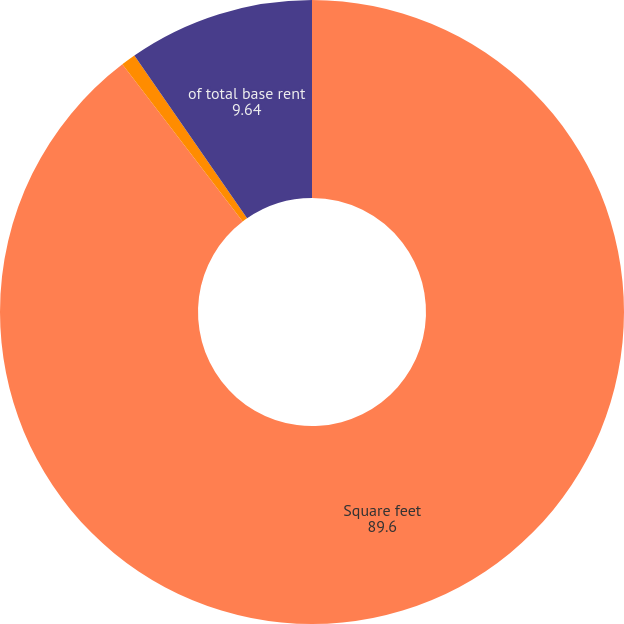Convert chart to OTSL. <chart><loc_0><loc_0><loc_500><loc_500><pie_chart><fcel>Square feet<fcel>of segment base rent<fcel>of total base rent<nl><fcel>89.6%<fcel>0.76%<fcel>9.64%<nl></chart> 